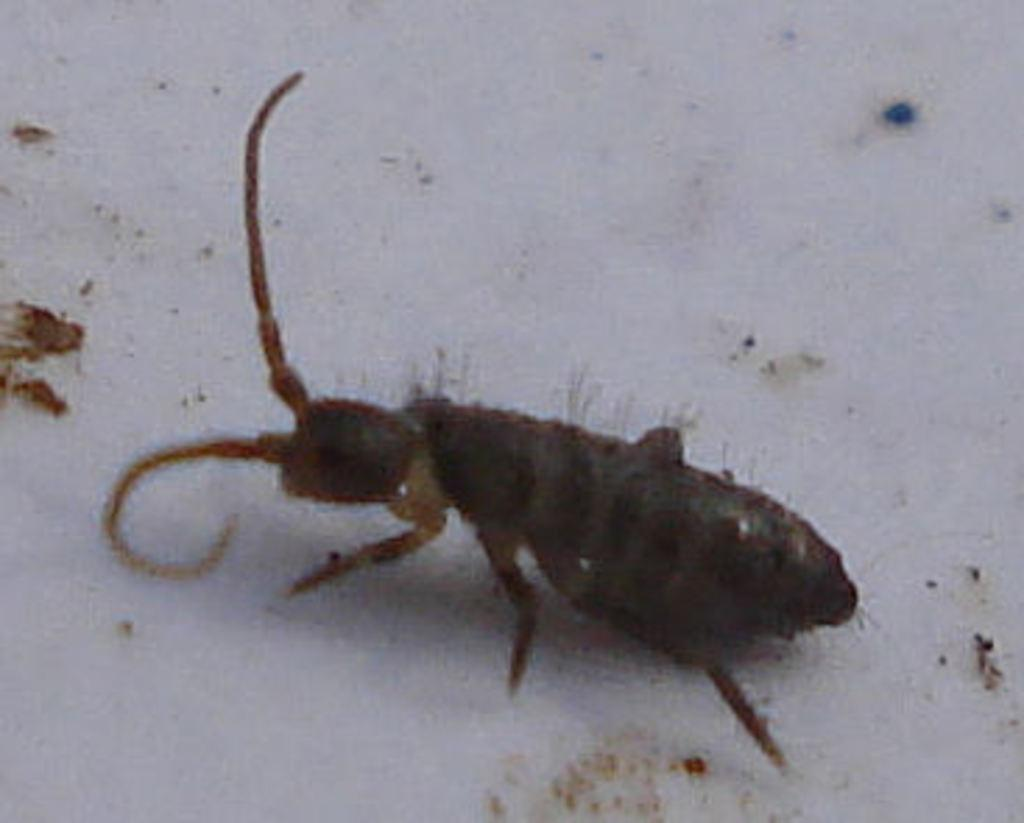What type of creature can be seen in the image? There is an insect in the image. What color is the background of the image? The background of the image is white. What type of engine is being used by the insect in the image? There is no engine present in the image, as it features an insect and not a vehicle or machine. 